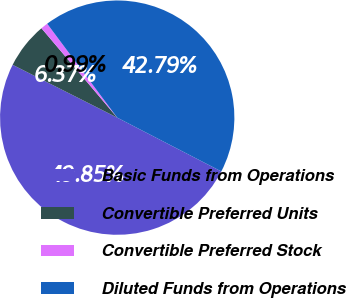Convert chart to OTSL. <chart><loc_0><loc_0><loc_500><loc_500><pie_chart><fcel>Basic Funds from Operations<fcel>Convertible Preferred Units<fcel>Convertible Preferred Stock<fcel>Diluted Funds from Operations<nl><fcel>49.85%<fcel>6.37%<fcel>0.99%<fcel>42.79%<nl></chart> 